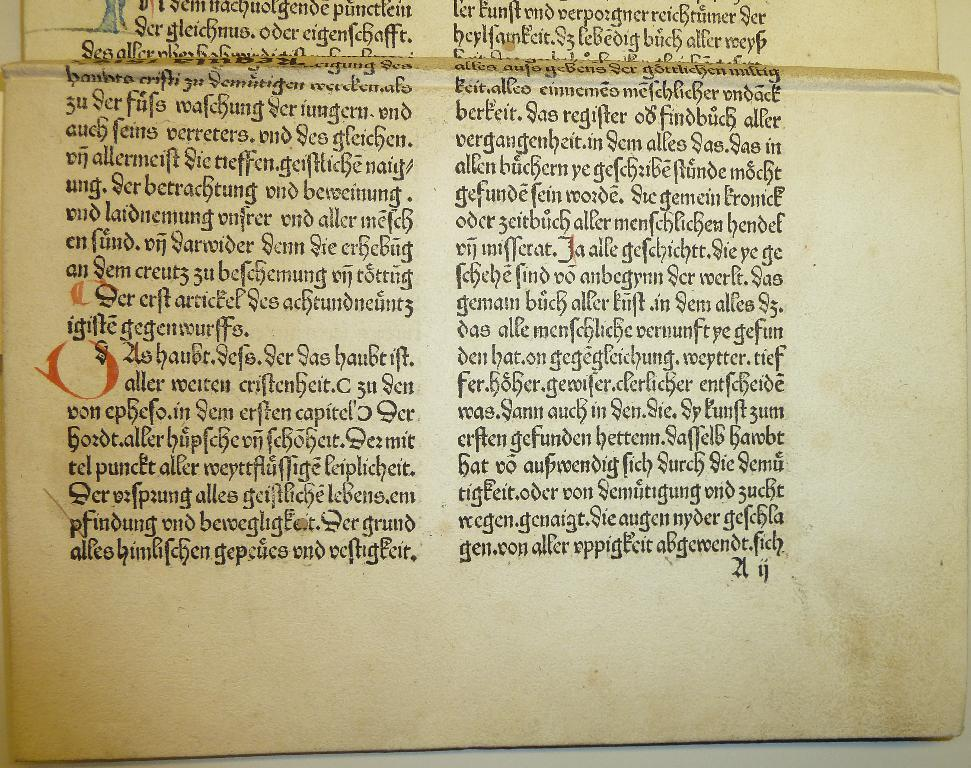<image>
Offer a succinct explanation of the picture presented. An old book written in German has the word alles in the text. 